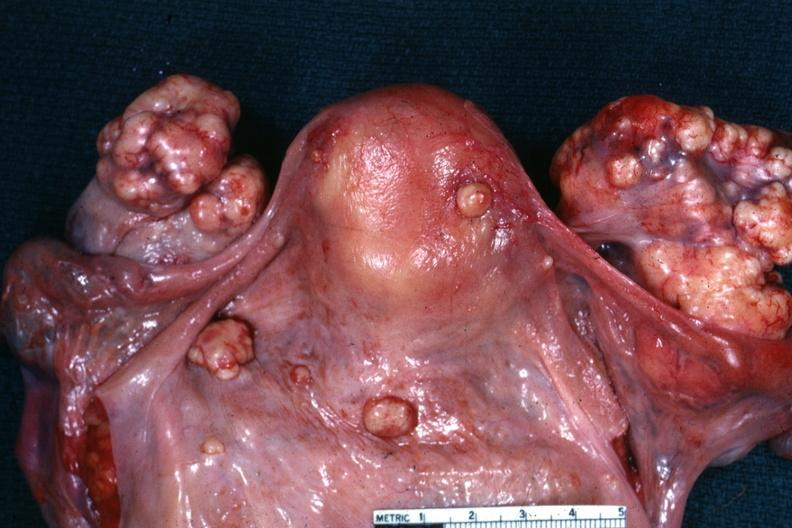what is present?
Answer the question using a single word or phrase. Ovary 